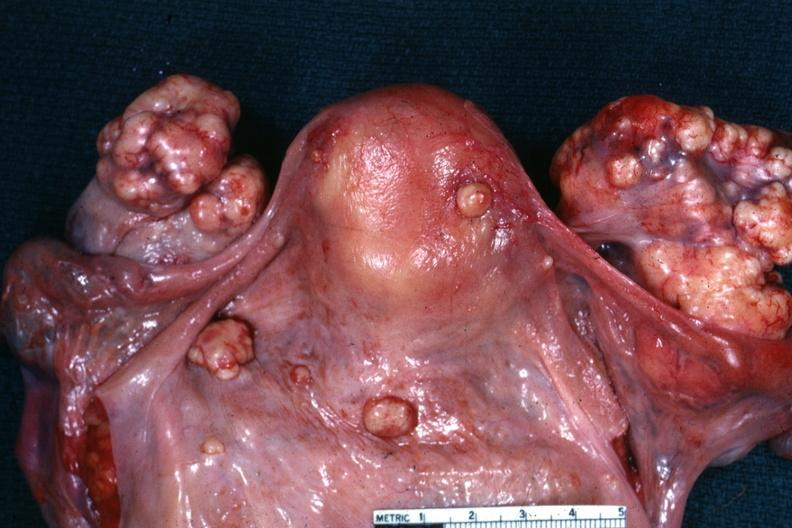what is present?
Answer the question using a single word or phrase. Ovary 